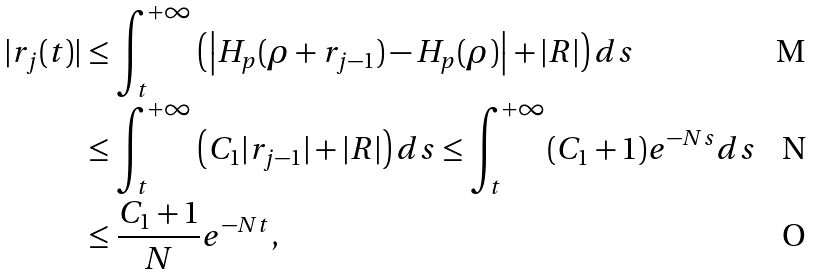Convert formula to latex. <formula><loc_0><loc_0><loc_500><loc_500>| r _ { j } ( t ) | & \leq \int _ { t } ^ { + \infty } \left ( \left | H _ { p } ( \rho + r _ { j - 1 } ) - H _ { p } ( \rho ) \right | + | R | \right ) d s \\ & \leq \int _ { t } ^ { + \infty } \left ( C _ { 1 } | r _ { j - 1 } | + | R | \right ) d s \leq \int _ { t } ^ { + \infty } ( C _ { 1 } + 1 ) e ^ { - N s } d s \\ & \leq \frac { C _ { 1 } + 1 } { N } e ^ { - N t } ,</formula> 